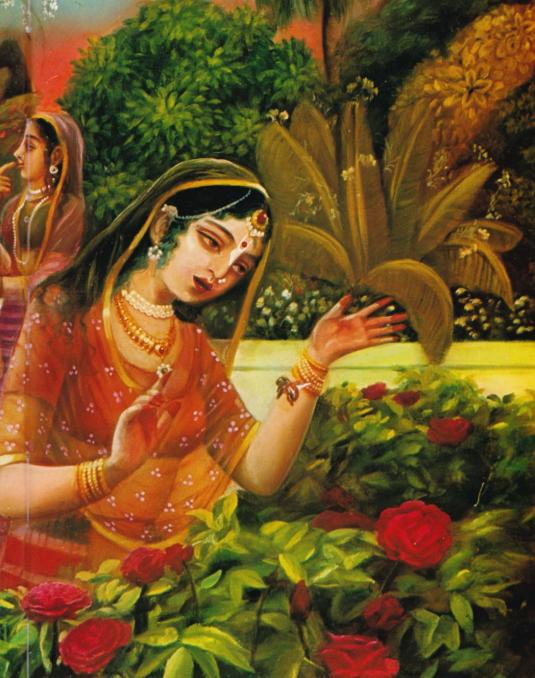If this painting were a scene from a famous Indian epic or mythology, which one might it be and why? This scene could be from the epic 'Mahabharata' or 'Ramayana', where numerous instances depict women in gardens or nature settings, engaging in moments of reflection or devotion. For example, it could represent Sita in the 'Ramayana,' appreciating nature in the Ashoka Vatika, symbolizing purity, resilience, and inner strength. The detailed attire and peaceful surroundings align well with epic narratives that emphasize the significance of nature and symbolic gestures. 